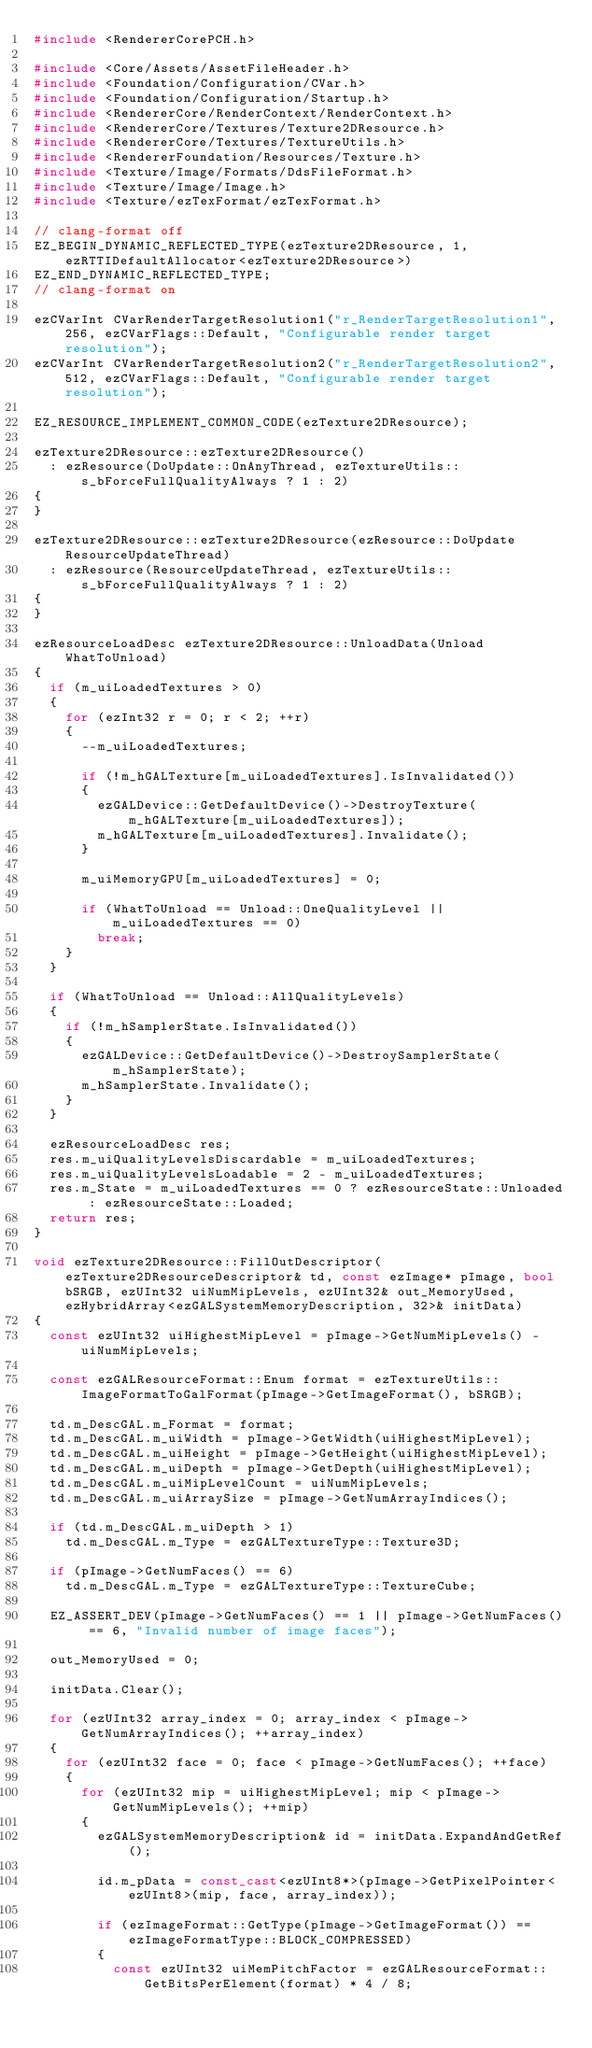Convert code to text. <code><loc_0><loc_0><loc_500><loc_500><_C++_>#include <RendererCorePCH.h>

#include <Core/Assets/AssetFileHeader.h>
#include <Foundation/Configuration/CVar.h>
#include <Foundation/Configuration/Startup.h>
#include <RendererCore/RenderContext/RenderContext.h>
#include <RendererCore/Textures/Texture2DResource.h>
#include <RendererCore/Textures/TextureUtils.h>
#include <RendererFoundation/Resources/Texture.h>
#include <Texture/Image/Formats/DdsFileFormat.h>
#include <Texture/Image/Image.h>
#include <Texture/ezTexFormat/ezTexFormat.h>

// clang-format off
EZ_BEGIN_DYNAMIC_REFLECTED_TYPE(ezTexture2DResource, 1, ezRTTIDefaultAllocator<ezTexture2DResource>)
EZ_END_DYNAMIC_REFLECTED_TYPE;
// clang-format on

ezCVarInt CVarRenderTargetResolution1("r_RenderTargetResolution1", 256, ezCVarFlags::Default, "Configurable render target resolution");
ezCVarInt CVarRenderTargetResolution2("r_RenderTargetResolution2", 512, ezCVarFlags::Default, "Configurable render target resolution");

EZ_RESOURCE_IMPLEMENT_COMMON_CODE(ezTexture2DResource);

ezTexture2DResource::ezTexture2DResource()
  : ezResource(DoUpdate::OnAnyThread, ezTextureUtils::s_bForceFullQualityAlways ? 1 : 2)
{
}

ezTexture2DResource::ezTexture2DResource(ezResource::DoUpdate ResourceUpdateThread)
  : ezResource(ResourceUpdateThread, ezTextureUtils::s_bForceFullQualityAlways ? 1 : 2)
{
}

ezResourceLoadDesc ezTexture2DResource::UnloadData(Unload WhatToUnload)
{
  if (m_uiLoadedTextures > 0)
  {
    for (ezInt32 r = 0; r < 2; ++r)
    {
      --m_uiLoadedTextures;

      if (!m_hGALTexture[m_uiLoadedTextures].IsInvalidated())
      {
        ezGALDevice::GetDefaultDevice()->DestroyTexture(m_hGALTexture[m_uiLoadedTextures]);
        m_hGALTexture[m_uiLoadedTextures].Invalidate();
      }

      m_uiMemoryGPU[m_uiLoadedTextures] = 0;

      if (WhatToUnload == Unload::OneQualityLevel || m_uiLoadedTextures == 0)
        break;
    }
  }

  if (WhatToUnload == Unload::AllQualityLevels)
  {
    if (!m_hSamplerState.IsInvalidated())
    {
      ezGALDevice::GetDefaultDevice()->DestroySamplerState(m_hSamplerState);
      m_hSamplerState.Invalidate();
    }
  }

  ezResourceLoadDesc res;
  res.m_uiQualityLevelsDiscardable = m_uiLoadedTextures;
  res.m_uiQualityLevelsLoadable = 2 - m_uiLoadedTextures;
  res.m_State = m_uiLoadedTextures == 0 ? ezResourceState::Unloaded : ezResourceState::Loaded;
  return res;
}

void ezTexture2DResource::FillOutDescriptor(ezTexture2DResourceDescriptor& td, const ezImage* pImage, bool bSRGB, ezUInt32 uiNumMipLevels, ezUInt32& out_MemoryUsed, ezHybridArray<ezGALSystemMemoryDescription, 32>& initData)
{
  const ezUInt32 uiHighestMipLevel = pImage->GetNumMipLevels() - uiNumMipLevels;

  const ezGALResourceFormat::Enum format = ezTextureUtils::ImageFormatToGalFormat(pImage->GetImageFormat(), bSRGB);

  td.m_DescGAL.m_Format = format;
  td.m_DescGAL.m_uiWidth = pImage->GetWidth(uiHighestMipLevel);
  td.m_DescGAL.m_uiHeight = pImage->GetHeight(uiHighestMipLevel);
  td.m_DescGAL.m_uiDepth = pImage->GetDepth(uiHighestMipLevel);
  td.m_DescGAL.m_uiMipLevelCount = uiNumMipLevels;
  td.m_DescGAL.m_uiArraySize = pImage->GetNumArrayIndices();

  if (td.m_DescGAL.m_uiDepth > 1)
    td.m_DescGAL.m_Type = ezGALTextureType::Texture3D;

  if (pImage->GetNumFaces() == 6)
    td.m_DescGAL.m_Type = ezGALTextureType::TextureCube;

  EZ_ASSERT_DEV(pImage->GetNumFaces() == 1 || pImage->GetNumFaces() == 6, "Invalid number of image faces");

  out_MemoryUsed = 0;

  initData.Clear();

  for (ezUInt32 array_index = 0; array_index < pImage->GetNumArrayIndices(); ++array_index)
  {
    for (ezUInt32 face = 0; face < pImage->GetNumFaces(); ++face)
    {
      for (ezUInt32 mip = uiHighestMipLevel; mip < pImage->GetNumMipLevels(); ++mip)
      {
        ezGALSystemMemoryDescription& id = initData.ExpandAndGetRef();

        id.m_pData = const_cast<ezUInt8*>(pImage->GetPixelPointer<ezUInt8>(mip, face, array_index));

        if (ezImageFormat::GetType(pImage->GetImageFormat()) == ezImageFormatType::BLOCK_COMPRESSED)
        {
          const ezUInt32 uiMemPitchFactor = ezGALResourceFormat::GetBitsPerElement(format) * 4 / 8;
</code> 